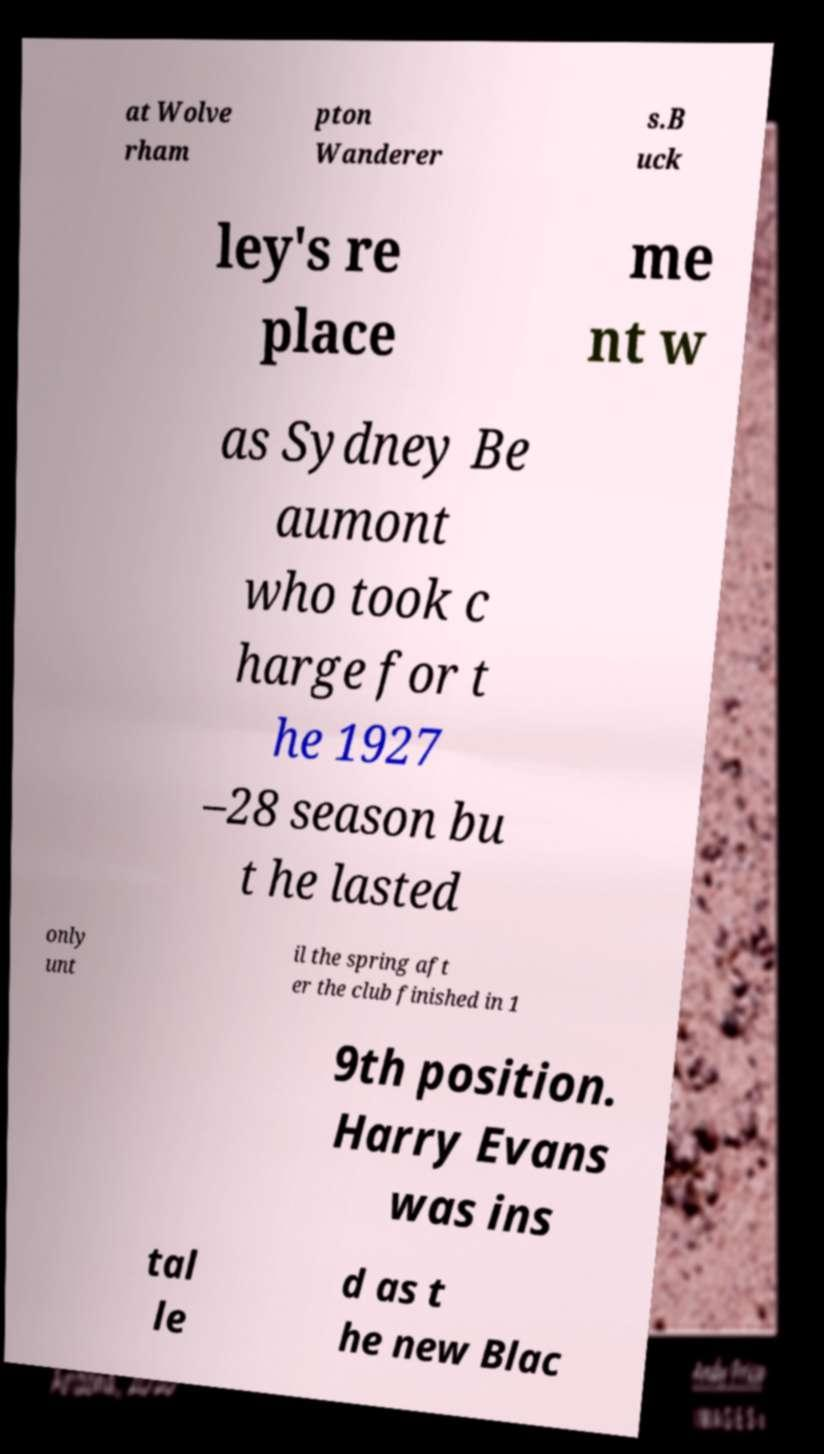I need the written content from this picture converted into text. Can you do that? at Wolve rham pton Wanderer s.B uck ley's re place me nt w as Sydney Be aumont who took c harge for t he 1927 –28 season bu t he lasted only unt il the spring aft er the club finished in 1 9th position. Harry Evans was ins tal le d as t he new Blac 